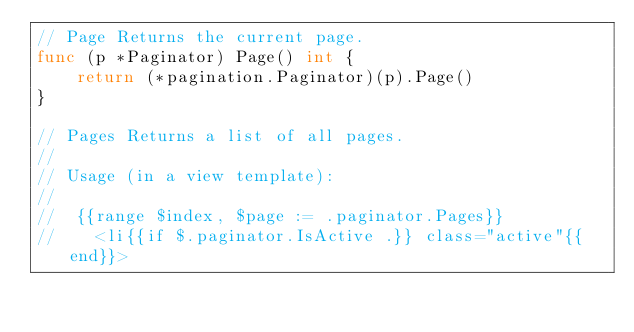Convert code to text. <code><loc_0><loc_0><loc_500><loc_500><_Go_>// Page Returns the current page.
func (p *Paginator) Page() int {
	return (*pagination.Paginator)(p).Page()
}

// Pages Returns a list of all pages.
//
// Usage (in a view template):
//
//  {{range $index, $page := .paginator.Pages}}
//    <li{{if $.paginator.IsActive .}} class="active"{{end}}></code> 